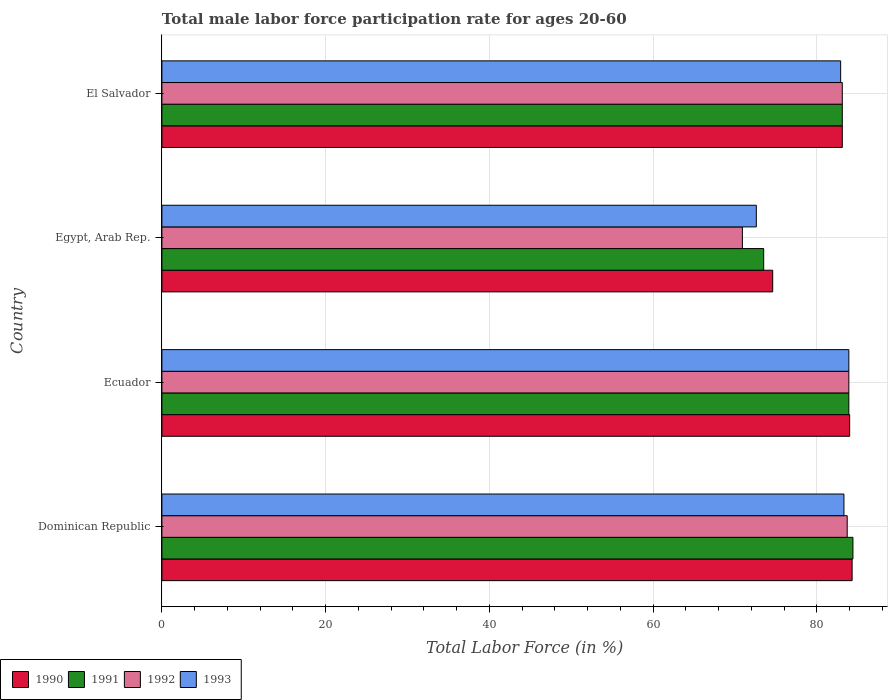How many groups of bars are there?
Keep it short and to the point. 4. Are the number of bars per tick equal to the number of legend labels?
Your answer should be compact. Yes. How many bars are there on the 2nd tick from the top?
Make the answer very short. 4. How many bars are there on the 3rd tick from the bottom?
Ensure brevity in your answer.  4. What is the label of the 1st group of bars from the top?
Give a very brief answer. El Salvador. What is the male labor force participation rate in 1991 in Ecuador?
Offer a terse response. 83.9. Across all countries, what is the maximum male labor force participation rate in 1991?
Your answer should be compact. 84.4. Across all countries, what is the minimum male labor force participation rate in 1992?
Your response must be concise. 70.9. In which country was the male labor force participation rate in 1992 maximum?
Provide a succinct answer. Ecuador. In which country was the male labor force participation rate in 1993 minimum?
Make the answer very short. Egypt, Arab Rep. What is the total male labor force participation rate in 1992 in the graph?
Offer a very short reply. 321.6. What is the difference between the male labor force participation rate in 1990 in Dominican Republic and that in Egypt, Arab Rep.?
Ensure brevity in your answer.  9.7. What is the difference between the male labor force participation rate in 1993 in Egypt, Arab Rep. and the male labor force participation rate in 1990 in Ecuador?
Offer a terse response. -11.4. What is the average male labor force participation rate in 1990 per country?
Provide a succinct answer. 81.5. What is the difference between the male labor force participation rate in 1993 and male labor force participation rate in 1992 in Ecuador?
Give a very brief answer. 0. In how many countries, is the male labor force participation rate in 1991 greater than 60 %?
Offer a terse response. 4. What is the ratio of the male labor force participation rate in 1991 in Ecuador to that in Egypt, Arab Rep.?
Provide a short and direct response. 1.14. Is the male labor force participation rate in 1991 in Ecuador less than that in Egypt, Arab Rep.?
Offer a very short reply. No. What is the difference between the highest and the second highest male labor force participation rate in 1992?
Make the answer very short. 0.2. What is the difference between the highest and the lowest male labor force participation rate in 1992?
Give a very brief answer. 13. In how many countries, is the male labor force participation rate in 1992 greater than the average male labor force participation rate in 1992 taken over all countries?
Your response must be concise. 3. Is it the case that in every country, the sum of the male labor force participation rate in 1991 and male labor force participation rate in 1990 is greater than the sum of male labor force participation rate in 1993 and male labor force participation rate in 1992?
Ensure brevity in your answer.  No. What does the 2nd bar from the top in Dominican Republic represents?
Your response must be concise. 1992. How many bars are there?
Provide a short and direct response. 16. Are all the bars in the graph horizontal?
Provide a succinct answer. Yes. How many countries are there in the graph?
Provide a succinct answer. 4. What is the difference between two consecutive major ticks on the X-axis?
Keep it short and to the point. 20. Are the values on the major ticks of X-axis written in scientific E-notation?
Offer a terse response. No. Does the graph contain any zero values?
Offer a very short reply. No. How many legend labels are there?
Ensure brevity in your answer.  4. How are the legend labels stacked?
Your answer should be compact. Horizontal. What is the title of the graph?
Offer a terse response. Total male labor force participation rate for ages 20-60. Does "1994" appear as one of the legend labels in the graph?
Offer a terse response. No. What is the Total Labor Force (in %) in 1990 in Dominican Republic?
Keep it short and to the point. 84.3. What is the Total Labor Force (in %) in 1991 in Dominican Republic?
Provide a succinct answer. 84.4. What is the Total Labor Force (in %) of 1992 in Dominican Republic?
Offer a terse response. 83.7. What is the Total Labor Force (in %) of 1993 in Dominican Republic?
Give a very brief answer. 83.3. What is the Total Labor Force (in %) in 1991 in Ecuador?
Your answer should be very brief. 83.9. What is the Total Labor Force (in %) of 1992 in Ecuador?
Your response must be concise. 83.9. What is the Total Labor Force (in %) in 1993 in Ecuador?
Give a very brief answer. 83.9. What is the Total Labor Force (in %) of 1990 in Egypt, Arab Rep.?
Keep it short and to the point. 74.6. What is the Total Labor Force (in %) in 1991 in Egypt, Arab Rep.?
Offer a terse response. 73.5. What is the Total Labor Force (in %) of 1992 in Egypt, Arab Rep.?
Ensure brevity in your answer.  70.9. What is the Total Labor Force (in %) of 1993 in Egypt, Arab Rep.?
Offer a terse response. 72.6. What is the Total Labor Force (in %) in 1990 in El Salvador?
Offer a terse response. 83.1. What is the Total Labor Force (in %) in 1991 in El Salvador?
Ensure brevity in your answer.  83.1. What is the Total Labor Force (in %) in 1992 in El Salvador?
Make the answer very short. 83.1. What is the Total Labor Force (in %) in 1993 in El Salvador?
Ensure brevity in your answer.  82.9. Across all countries, what is the maximum Total Labor Force (in %) in 1990?
Keep it short and to the point. 84.3. Across all countries, what is the maximum Total Labor Force (in %) of 1991?
Give a very brief answer. 84.4. Across all countries, what is the maximum Total Labor Force (in %) of 1992?
Make the answer very short. 83.9. Across all countries, what is the maximum Total Labor Force (in %) of 1993?
Offer a very short reply. 83.9. Across all countries, what is the minimum Total Labor Force (in %) in 1990?
Ensure brevity in your answer.  74.6. Across all countries, what is the minimum Total Labor Force (in %) in 1991?
Your response must be concise. 73.5. Across all countries, what is the minimum Total Labor Force (in %) in 1992?
Your response must be concise. 70.9. Across all countries, what is the minimum Total Labor Force (in %) in 1993?
Keep it short and to the point. 72.6. What is the total Total Labor Force (in %) in 1990 in the graph?
Provide a succinct answer. 326. What is the total Total Labor Force (in %) of 1991 in the graph?
Give a very brief answer. 324.9. What is the total Total Labor Force (in %) in 1992 in the graph?
Offer a very short reply. 321.6. What is the total Total Labor Force (in %) of 1993 in the graph?
Offer a terse response. 322.7. What is the difference between the Total Labor Force (in %) in 1991 in Dominican Republic and that in Ecuador?
Offer a terse response. 0.5. What is the difference between the Total Labor Force (in %) in 1990 in Dominican Republic and that in Egypt, Arab Rep.?
Offer a very short reply. 9.7. What is the difference between the Total Labor Force (in %) in 1992 in Dominican Republic and that in Egypt, Arab Rep.?
Provide a short and direct response. 12.8. What is the difference between the Total Labor Force (in %) in 1991 in Dominican Republic and that in El Salvador?
Offer a very short reply. 1.3. What is the difference between the Total Labor Force (in %) of 1993 in Dominican Republic and that in El Salvador?
Offer a terse response. 0.4. What is the difference between the Total Labor Force (in %) of 1991 in Ecuador and that in Egypt, Arab Rep.?
Provide a succinct answer. 10.4. What is the difference between the Total Labor Force (in %) in 1993 in Ecuador and that in Egypt, Arab Rep.?
Provide a short and direct response. 11.3. What is the difference between the Total Labor Force (in %) of 1990 in Ecuador and that in El Salvador?
Offer a terse response. 0.9. What is the difference between the Total Labor Force (in %) in 1991 in Egypt, Arab Rep. and that in El Salvador?
Offer a terse response. -9.6. What is the difference between the Total Labor Force (in %) in 1992 in Egypt, Arab Rep. and that in El Salvador?
Provide a short and direct response. -12.2. What is the difference between the Total Labor Force (in %) of 1990 in Dominican Republic and the Total Labor Force (in %) of 1992 in Ecuador?
Provide a succinct answer. 0.4. What is the difference between the Total Labor Force (in %) in 1991 in Dominican Republic and the Total Labor Force (in %) in 1992 in Ecuador?
Your answer should be compact. 0.5. What is the difference between the Total Labor Force (in %) in 1991 in Dominican Republic and the Total Labor Force (in %) in 1993 in Ecuador?
Provide a short and direct response. 0.5. What is the difference between the Total Labor Force (in %) in 1992 in Dominican Republic and the Total Labor Force (in %) in 1993 in Ecuador?
Keep it short and to the point. -0.2. What is the difference between the Total Labor Force (in %) in 1990 in Dominican Republic and the Total Labor Force (in %) in 1991 in Egypt, Arab Rep.?
Your response must be concise. 10.8. What is the difference between the Total Labor Force (in %) in 1990 in Dominican Republic and the Total Labor Force (in %) in 1992 in Egypt, Arab Rep.?
Offer a very short reply. 13.4. What is the difference between the Total Labor Force (in %) in 1990 in Dominican Republic and the Total Labor Force (in %) in 1991 in El Salvador?
Your response must be concise. 1.2. What is the difference between the Total Labor Force (in %) in 1990 in Dominican Republic and the Total Labor Force (in %) in 1993 in El Salvador?
Offer a terse response. 1.4. What is the difference between the Total Labor Force (in %) of 1991 in Dominican Republic and the Total Labor Force (in %) of 1992 in El Salvador?
Keep it short and to the point. 1.3. What is the difference between the Total Labor Force (in %) in 1990 in Ecuador and the Total Labor Force (in %) in 1991 in Egypt, Arab Rep.?
Keep it short and to the point. 10.5. What is the difference between the Total Labor Force (in %) in 1990 in Ecuador and the Total Labor Force (in %) in 1992 in Egypt, Arab Rep.?
Provide a short and direct response. 13.1. What is the difference between the Total Labor Force (in %) of 1991 in Ecuador and the Total Labor Force (in %) of 1992 in Egypt, Arab Rep.?
Provide a short and direct response. 13. What is the difference between the Total Labor Force (in %) of 1991 in Ecuador and the Total Labor Force (in %) of 1993 in Egypt, Arab Rep.?
Provide a short and direct response. 11.3. What is the difference between the Total Labor Force (in %) of 1991 in Ecuador and the Total Labor Force (in %) of 1993 in El Salvador?
Provide a short and direct response. 1. What is the difference between the Total Labor Force (in %) of 1990 in Egypt, Arab Rep. and the Total Labor Force (in %) of 1991 in El Salvador?
Give a very brief answer. -8.5. What is the difference between the Total Labor Force (in %) in 1991 in Egypt, Arab Rep. and the Total Labor Force (in %) in 1993 in El Salvador?
Keep it short and to the point. -9.4. What is the difference between the Total Labor Force (in %) of 1992 in Egypt, Arab Rep. and the Total Labor Force (in %) of 1993 in El Salvador?
Keep it short and to the point. -12. What is the average Total Labor Force (in %) of 1990 per country?
Keep it short and to the point. 81.5. What is the average Total Labor Force (in %) of 1991 per country?
Provide a short and direct response. 81.22. What is the average Total Labor Force (in %) in 1992 per country?
Keep it short and to the point. 80.4. What is the average Total Labor Force (in %) in 1993 per country?
Provide a short and direct response. 80.67. What is the difference between the Total Labor Force (in %) in 1990 and Total Labor Force (in %) in 1992 in Dominican Republic?
Keep it short and to the point. 0.6. What is the difference between the Total Labor Force (in %) of 1991 and Total Labor Force (in %) of 1992 in Dominican Republic?
Your response must be concise. 0.7. What is the difference between the Total Labor Force (in %) of 1990 and Total Labor Force (in %) of 1991 in Ecuador?
Provide a short and direct response. 0.1. What is the difference between the Total Labor Force (in %) in 1990 and Total Labor Force (in %) in 1993 in Ecuador?
Provide a short and direct response. 0.1. What is the difference between the Total Labor Force (in %) in 1991 and Total Labor Force (in %) in 1992 in Ecuador?
Your response must be concise. 0. What is the difference between the Total Labor Force (in %) of 1991 and Total Labor Force (in %) of 1993 in Ecuador?
Give a very brief answer. 0. What is the difference between the Total Labor Force (in %) in 1992 and Total Labor Force (in %) in 1993 in Ecuador?
Provide a succinct answer. 0. What is the difference between the Total Labor Force (in %) of 1990 and Total Labor Force (in %) of 1991 in Egypt, Arab Rep.?
Make the answer very short. 1.1. What is the difference between the Total Labor Force (in %) in 1991 and Total Labor Force (in %) in 1992 in Egypt, Arab Rep.?
Make the answer very short. 2.6. What is the difference between the Total Labor Force (in %) of 1991 and Total Labor Force (in %) of 1993 in Egypt, Arab Rep.?
Your response must be concise. 0.9. What is the difference between the Total Labor Force (in %) in 1990 and Total Labor Force (in %) in 1991 in El Salvador?
Give a very brief answer. 0. What is the difference between the Total Labor Force (in %) of 1992 and Total Labor Force (in %) of 1993 in El Salvador?
Offer a very short reply. 0.2. What is the ratio of the Total Labor Force (in %) in 1992 in Dominican Republic to that in Ecuador?
Your answer should be compact. 1. What is the ratio of the Total Labor Force (in %) of 1993 in Dominican Republic to that in Ecuador?
Give a very brief answer. 0.99. What is the ratio of the Total Labor Force (in %) of 1990 in Dominican Republic to that in Egypt, Arab Rep.?
Ensure brevity in your answer.  1.13. What is the ratio of the Total Labor Force (in %) in 1991 in Dominican Republic to that in Egypt, Arab Rep.?
Your answer should be compact. 1.15. What is the ratio of the Total Labor Force (in %) of 1992 in Dominican Republic to that in Egypt, Arab Rep.?
Make the answer very short. 1.18. What is the ratio of the Total Labor Force (in %) in 1993 in Dominican Republic to that in Egypt, Arab Rep.?
Your answer should be very brief. 1.15. What is the ratio of the Total Labor Force (in %) of 1990 in Dominican Republic to that in El Salvador?
Your answer should be compact. 1.01. What is the ratio of the Total Labor Force (in %) in 1991 in Dominican Republic to that in El Salvador?
Give a very brief answer. 1.02. What is the ratio of the Total Labor Force (in %) in 1992 in Dominican Republic to that in El Salvador?
Your answer should be compact. 1.01. What is the ratio of the Total Labor Force (in %) of 1993 in Dominican Republic to that in El Salvador?
Offer a very short reply. 1. What is the ratio of the Total Labor Force (in %) of 1990 in Ecuador to that in Egypt, Arab Rep.?
Keep it short and to the point. 1.13. What is the ratio of the Total Labor Force (in %) in 1991 in Ecuador to that in Egypt, Arab Rep.?
Make the answer very short. 1.14. What is the ratio of the Total Labor Force (in %) of 1992 in Ecuador to that in Egypt, Arab Rep.?
Offer a very short reply. 1.18. What is the ratio of the Total Labor Force (in %) of 1993 in Ecuador to that in Egypt, Arab Rep.?
Your answer should be compact. 1.16. What is the ratio of the Total Labor Force (in %) in 1990 in Ecuador to that in El Salvador?
Offer a terse response. 1.01. What is the ratio of the Total Labor Force (in %) in 1991 in Ecuador to that in El Salvador?
Your answer should be compact. 1.01. What is the ratio of the Total Labor Force (in %) in 1992 in Ecuador to that in El Salvador?
Your answer should be compact. 1.01. What is the ratio of the Total Labor Force (in %) in 1993 in Ecuador to that in El Salvador?
Your answer should be very brief. 1.01. What is the ratio of the Total Labor Force (in %) of 1990 in Egypt, Arab Rep. to that in El Salvador?
Offer a terse response. 0.9. What is the ratio of the Total Labor Force (in %) of 1991 in Egypt, Arab Rep. to that in El Salvador?
Give a very brief answer. 0.88. What is the ratio of the Total Labor Force (in %) of 1992 in Egypt, Arab Rep. to that in El Salvador?
Make the answer very short. 0.85. What is the ratio of the Total Labor Force (in %) of 1993 in Egypt, Arab Rep. to that in El Salvador?
Provide a succinct answer. 0.88. What is the difference between the highest and the second highest Total Labor Force (in %) in 1990?
Provide a succinct answer. 0.3. What is the difference between the highest and the second highest Total Labor Force (in %) of 1991?
Keep it short and to the point. 0.5. What is the difference between the highest and the second highest Total Labor Force (in %) in 1992?
Your answer should be compact. 0.2. What is the difference between the highest and the second highest Total Labor Force (in %) of 1993?
Make the answer very short. 0.6. What is the difference between the highest and the lowest Total Labor Force (in %) in 1991?
Give a very brief answer. 10.9. What is the difference between the highest and the lowest Total Labor Force (in %) in 1992?
Your answer should be very brief. 13. 